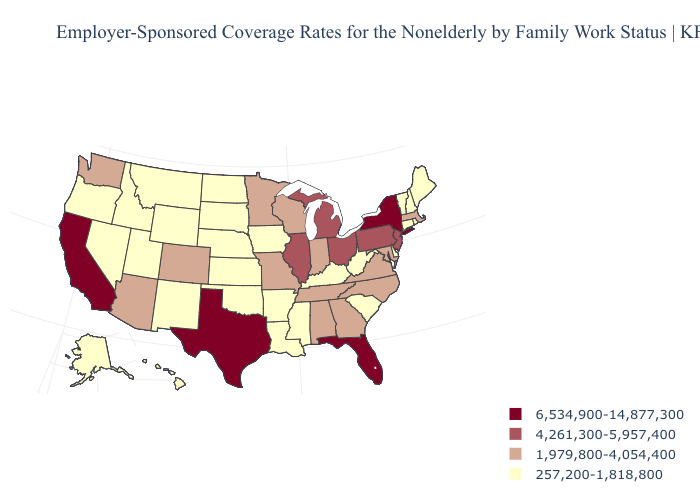Does Hawaii have the lowest value in the USA?
Concise answer only. Yes. Does California have the lowest value in the USA?
Keep it brief. No. Does Arizona have the lowest value in the USA?
Give a very brief answer. No. Name the states that have a value in the range 6,534,900-14,877,300?
Keep it brief. California, Florida, New York, Texas. What is the lowest value in states that border West Virginia?
Write a very short answer. 257,200-1,818,800. Does the map have missing data?
Quick response, please. No. What is the value of Arkansas?
Short answer required. 257,200-1,818,800. What is the highest value in the Northeast ?
Quick response, please. 6,534,900-14,877,300. Is the legend a continuous bar?
Be succinct. No. What is the value of Kansas?
Quick response, please. 257,200-1,818,800. Does Iowa have the lowest value in the MidWest?
Be succinct. Yes. Which states have the lowest value in the South?
Quick response, please. Arkansas, Delaware, Kentucky, Louisiana, Mississippi, Oklahoma, South Carolina, West Virginia. Which states hav the highest value in the Northeast?
Keep it brief. New York. What is the lowest value in the USA?
Quick response, please. 257,200-1,818,800. Does Indiana have a lower value than Michigan?
Give a very brief answer. Yes. 